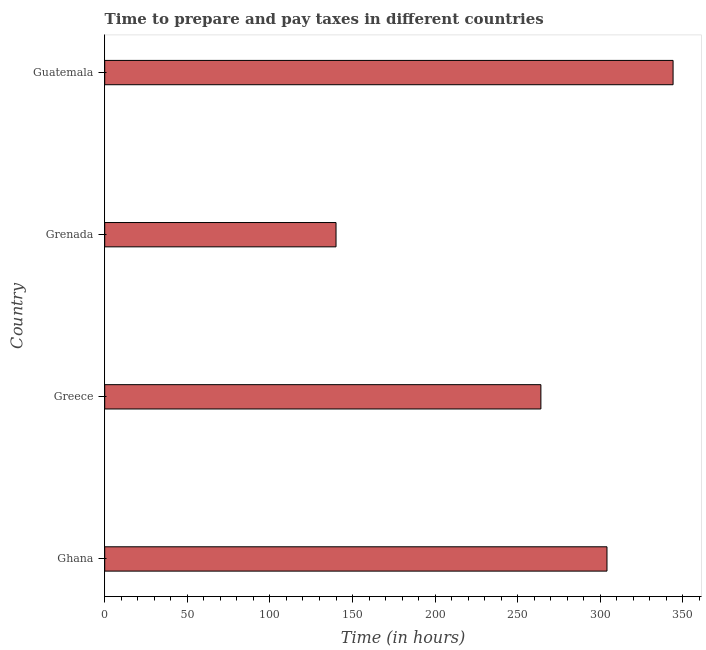Does the graph contain grids?
Provide a succinct answer. No. What is the title of the graph?
Offer a terse response. Time to prepare and pay taxes in different countries. What is the label or title of the X-axis?
Offer a terse response. Time (in hours). What is the label or title of the Y-axis?
Give a very brief answer. Country. What is the time to prepare and pay taxes in Guatemala?
Your answer should be compact. 344. Across all countries, what is the maximum time to prepare and pay taxes?
Give a very brief answer. 344. Across all countries, what is the minimum time to prepare and pay taxes?
Ensure brevity in your answer.  140. In which country was the time to prepare and pay taxes maximum?
Your answer should be very brief. Guatemala. In which country was the time to prepare and pay taxes minimum?
Provide a short and direct response. Grenada. What is the sum of the time to prepare and pay taxes?
Provide a short and direct response. 1052. What is the difference between the time to prepare and pay taxes in Greece and Grenada?
Make the answer very short. 124. What is the average time to prepare and pay taxes per country?
Make the answer very short. 263. What is the median time to prepare and pay taxes?
Offer a very short reply. 284. In how many countries, is the time to prepare and pay taxes greater than 300 hours?
Your answer should be very brief. 2. What is the ratio of the time to prepare and pay taxes in Ghana to that in Guatemala?
Offer a terse response. 0.88. What is the difference between the highest and the lowest time to prepare and pay taxes?
Give a very brief answer. 204. In how many countries, is the time to prepare and pay taxes greater than the average time to prepare and pay taxes taken over all countries?
Make the answer very short. 3. How many countries are there in the graph?
Your response must be concise. 4. What is the Time (in hours) of Ghana?
Make the answer very short. 304. What is the Time (in hours) in Greece?
Offer a terse response. 264. What is the Time (in hours) in Grenada?
Your answer should be compact. 140. What is the Time (in hours) in Guatemala?
Keep it short and to the point. 344. What is the difference between the Time (in hours) in Ghana and Grenada?
Your response must be concise. 164. What is the difference between the Time (in hours) in Greece and Grenada?
Offer a terse response. 124. What is the difference between the Time (in hours) in Greece and Guatemala?
Offer a terse response. -80. What is the difference between the Time (in hours) in Grenada and Guatemala?
Your answer should be compact. -204. What is the ratio of the Time (in hours) in Ghana to that in Greece?
Your response must be concise. 1.15. What is the ratio of the Time (in hours) in Ghana to that in Grenada?
Your answer should be very brief. 2.17. What is the ratio of the Time (in hours) in Ghana to that in Guatemala?
Give a very brief answer. 0.88. What is the ratio of the Time (in hours) in Greece to that in Grenada?
Your answer should be very brief. 1.89. What is the ratio of the Time (in hours) in Greece to that in Guatemala?
Provide a succinct answer. 0.77. What is the ratio of the Time (in hours) in Grenada to that in Guatemala?
Provide a short and direct response. 0.41. 